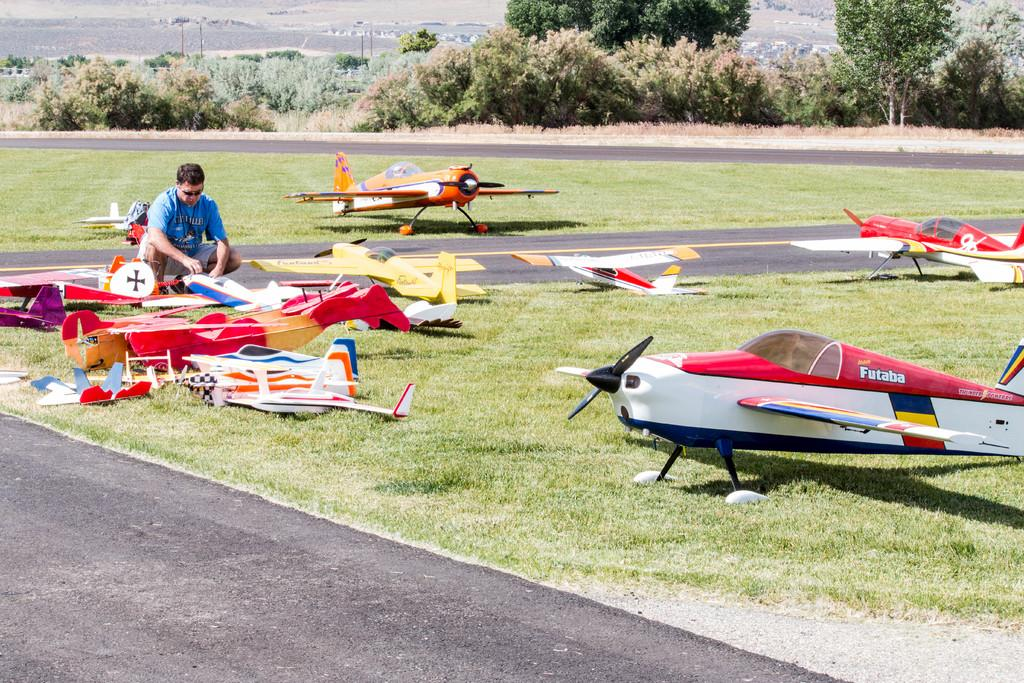Provide a one-sentence caption for the provided image. a very small aircraft with the word Futaba on it. 